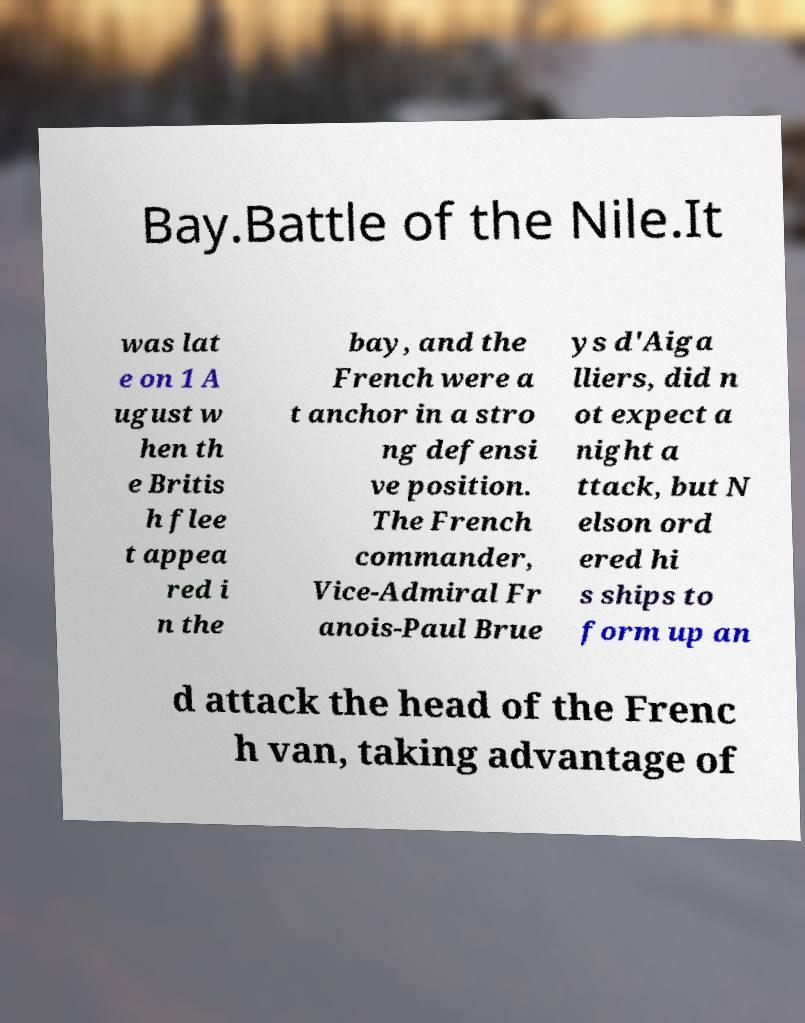Could you assist in decoding the text presented in this image and type it out clearly? Bay.Battle of the Nile.It was lat e on 1 A ugust w hen th e Britis h flee t appea red i n the bay, and the French were a t anchor in a stro ng defensi ve position. The French commander, Vice-Admiral Fr anois-Paul Brue ys d'Aiga lliers, did n ot expect a night a ttack, but N elson ord ered hi s ships to form up an d attack the head of the Frenc h van, taking advantage of 